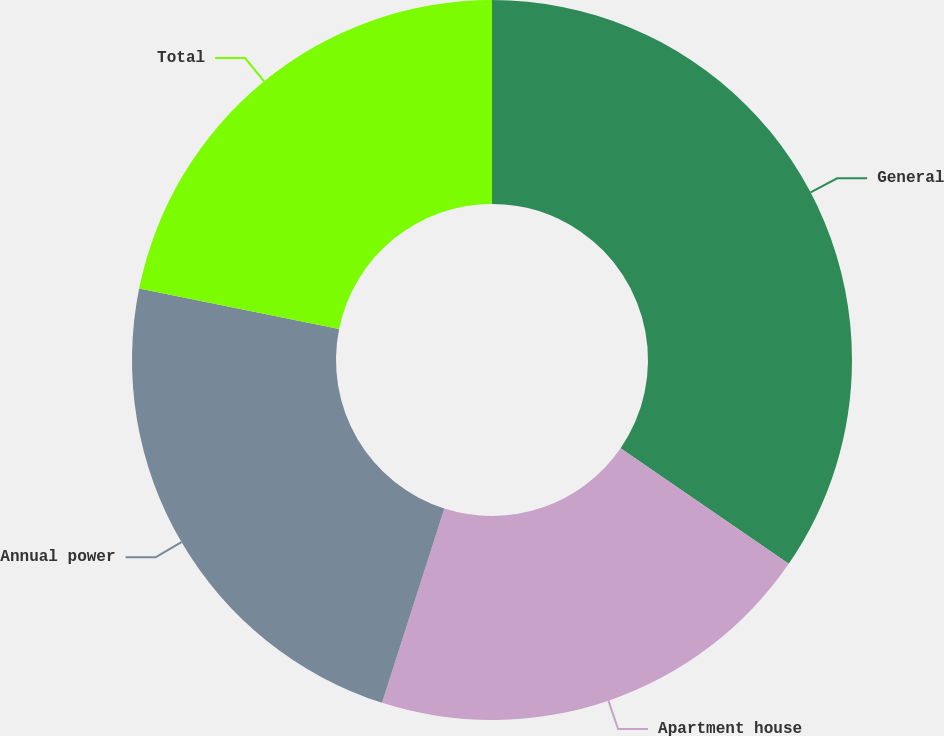<chart> <loc_0><loc_0><loc_500><loc_500><pie_chart><fcel>General<fcel>Apartment house<fcel>Annual power<fcel>Total<nl><fcel>34.58%<fcel>20.36%<fcel>23.24%<fcel>21.82%<nl></chart> 